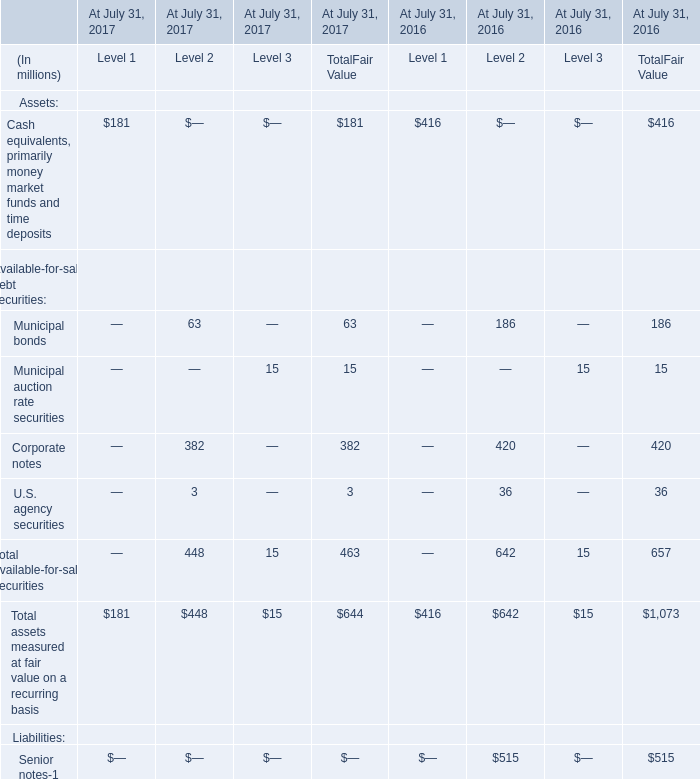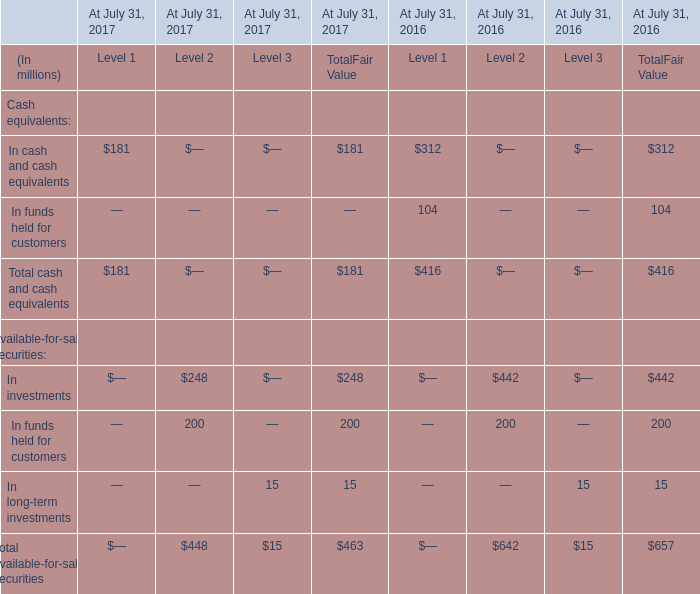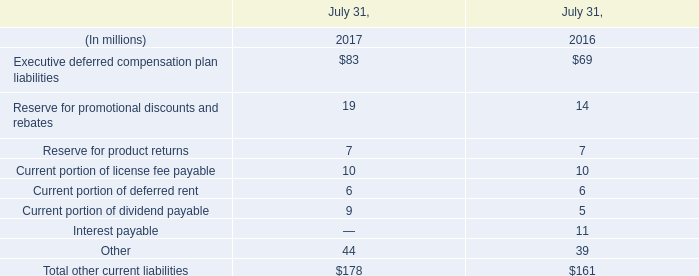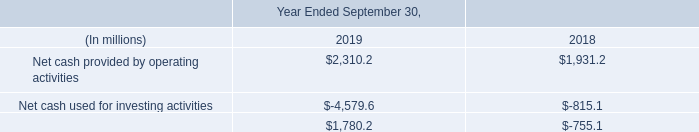in 2018 what was the percent of the net cash used for financing activities used for the purchase of purchases of common stock 
Computations: (195.1 / 755.1)
Answer: 0.25838. 